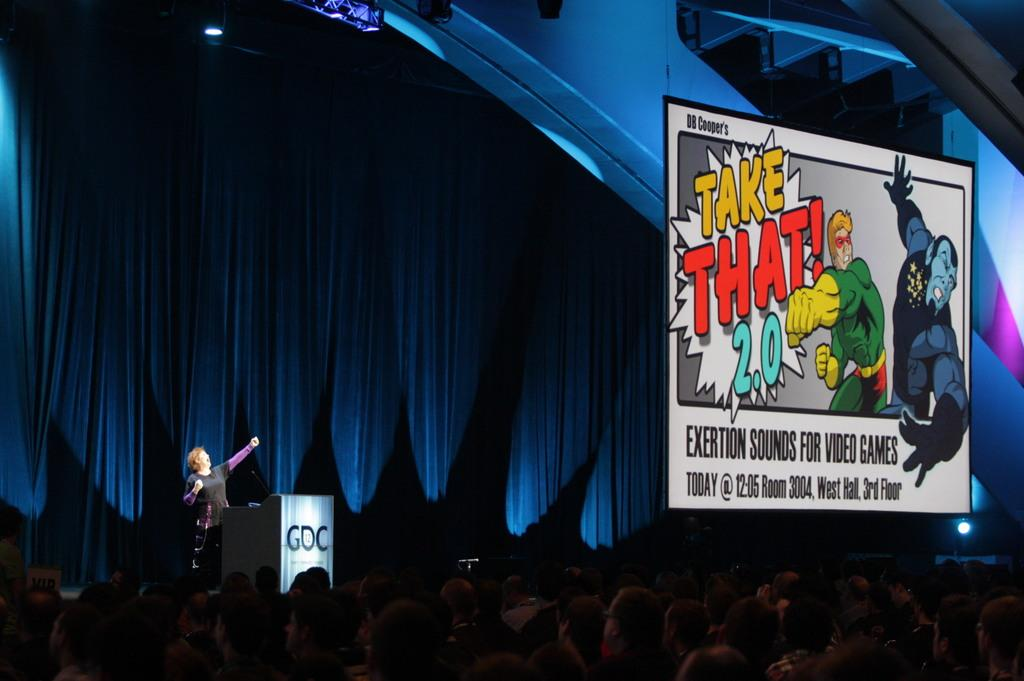What is the main subject of the image? There is a person standing in the image. What object is present near the person? There is a podium in the image. Who else is present in the image besides the person at the podium? There are people at the bottom of the image. What can be seen on the wall in the image? There is a board visible in the image. What can be seen in the background of the image? There is a curtain and lights visible in the background of the image. What type of texture can be seen on the bat in the image? There is no bat present in the image. What reward is the person at the podium receiving for their speech? The image does not provide information about any rewards or recognition for the person at the podium. 